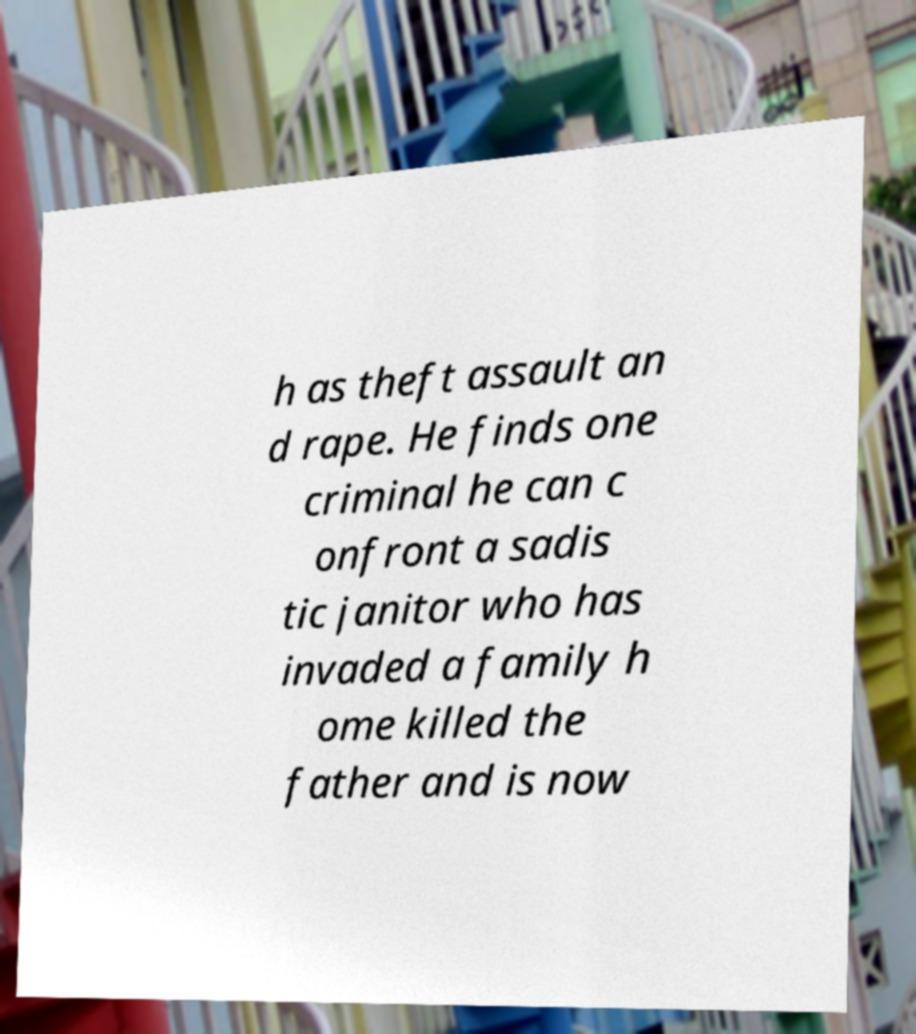For documentation purposes, I need the text within this image transcribed. Could you provide that? h as theft assault an d rape. He finds one criminal he can c onfront a sadis tic janitor who has invaded a family h ome killed the father and is now 